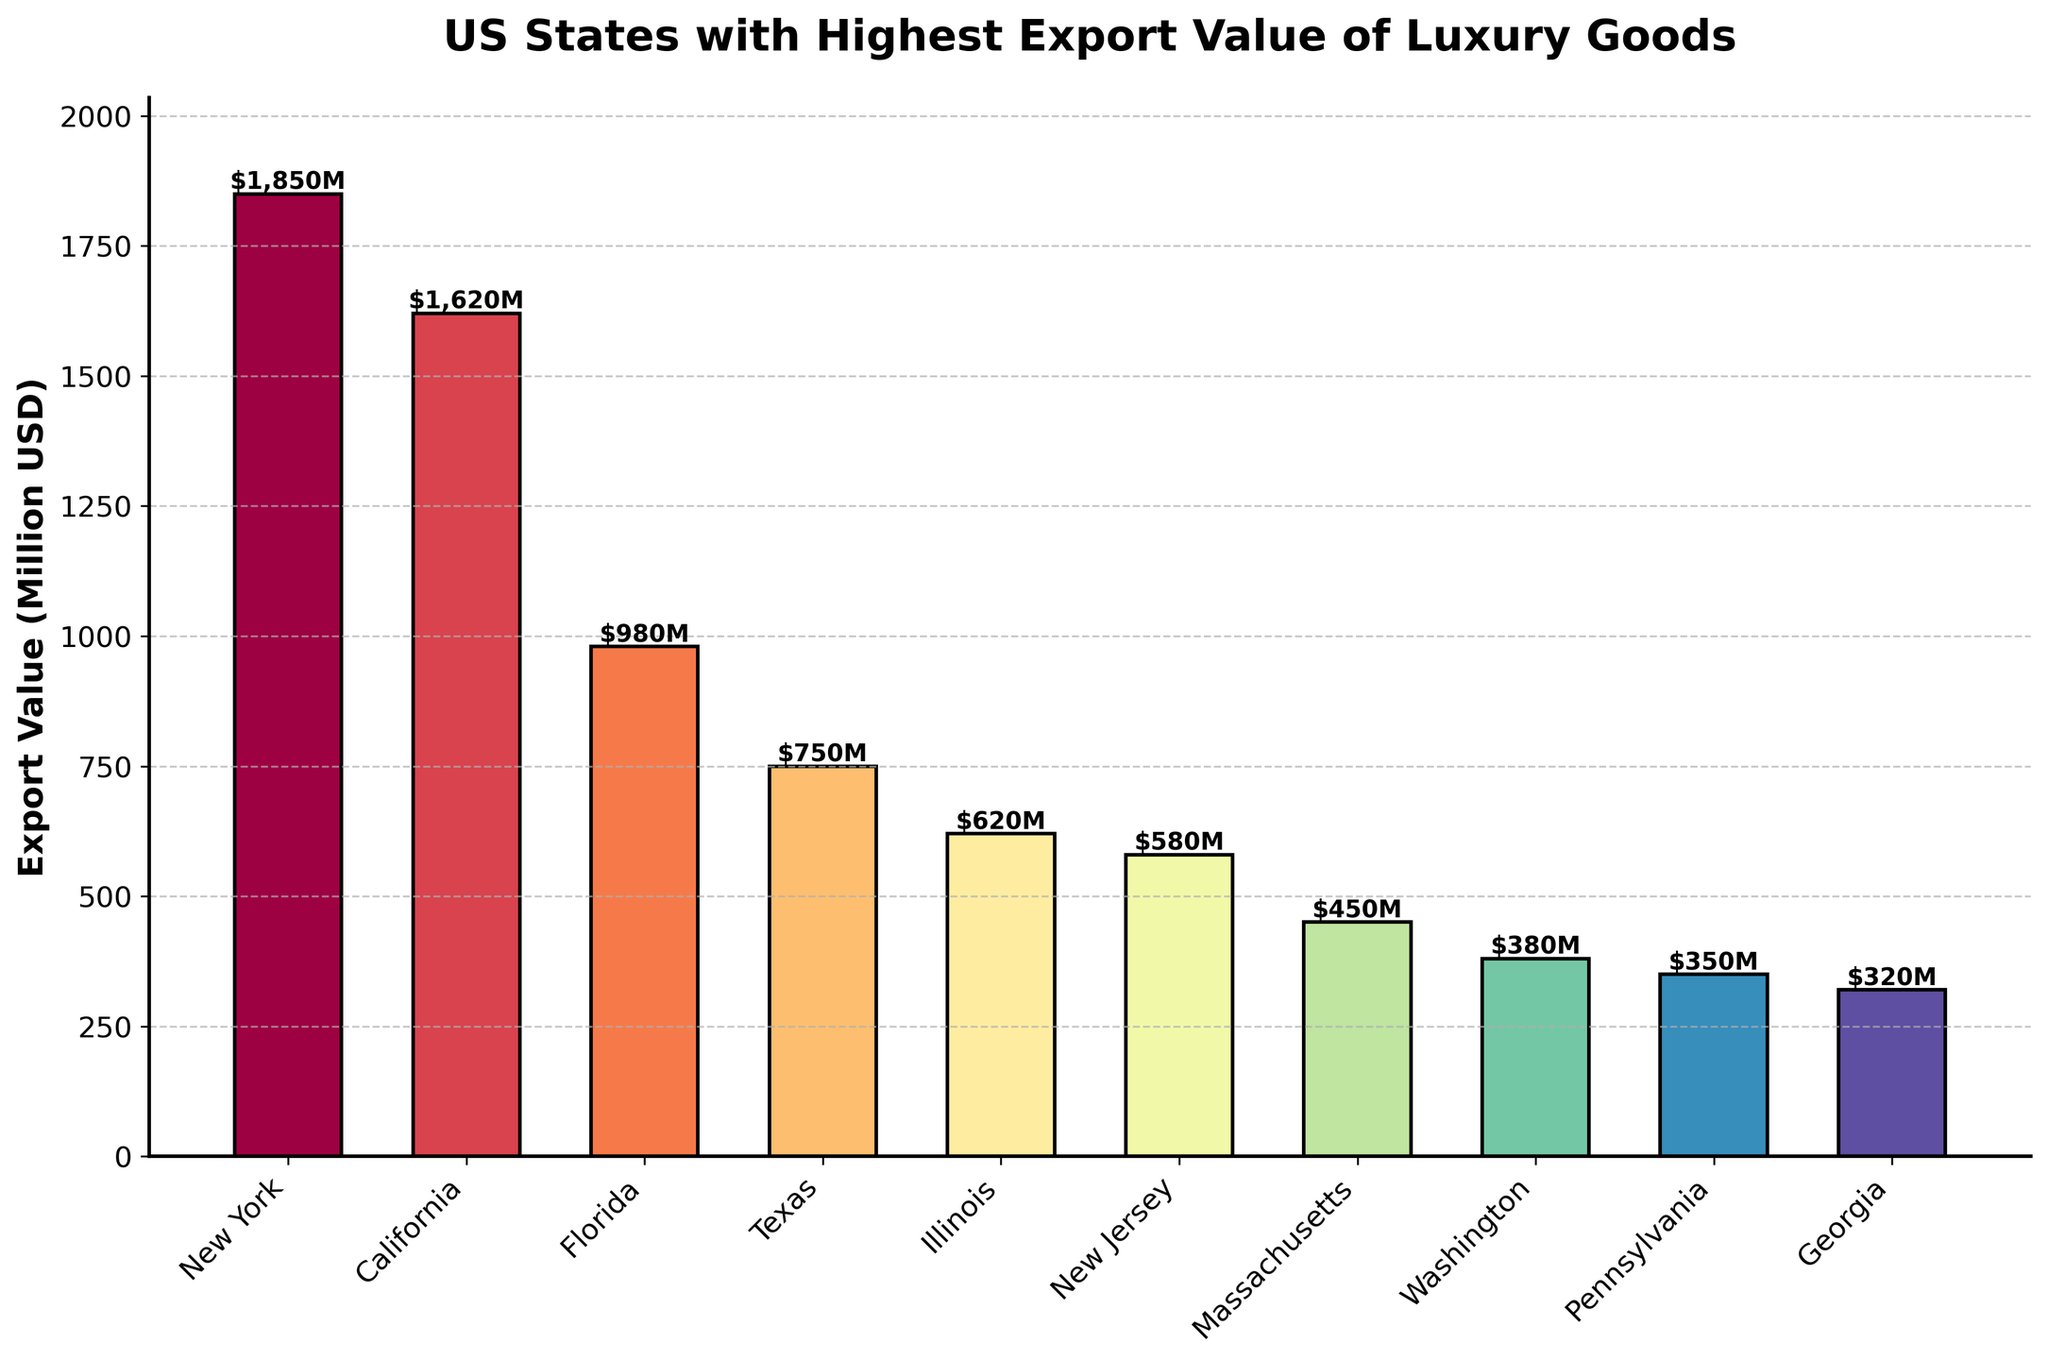What is the export value difference between New York and Texas? New York has an export value of 1850 million USD and Texas has 750 million USD. Subtracting the value of Texas from New York: 1850 - 750 = 1100 million USD.
Answer: 1100 million USD Which state has the highest export value of luxury goods? By visually inspecting the bar heights, New York has the highest bar. Therefore, New York has the highest export value.
Answer: New York What is the combined export value of Florida and Illinois? Florida has an export value of 980 million USD and Illinois has 620 million USD. Adding these values together: 980 + 620 = 1600 million USD.
Answer: 1600 million USD Rank the top three states based on export value of luxury goods. The top three states by descending bar height are New York (1850 million USD), California (1620 million USD), and Florida (980 million USD).
Answer: New York, California, Florida Which state has a lower export value, New Jersey or Georgia? By comparing the heights of the bars, New Jersey has an export value of 580 million USD, while Georgia has 320 million USD. Georgia’s bar is lower.
Answer: Georgia What is the average export value of the top five states? The export values of the top five states are: New York (1850), California (1620), Florida (980), Texas (750), and Illinois (620). Adding these values together: 1850 + 1620 + 980 + 750 + 620 = 5820 million USD, and then dividing by 5: 5820 / 5 = 1164 million USD.
Answer: 1164 million USD How much higher is the export value of Massachusetts compared to Washington? Massachusetts has an export value of 450 million USD and Washington has 380 million USD. Subtracting Washington’s value from Massachusetts: 450 - 380 = 70 million USD.
Answer: 70 million USD Describe the general trend as you move from New York to Georgia based on export values. The bars generally decrease in height from New York (1850 million USD) to Georgia (320 million USD).
Answer: Decreasing trend 